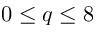Convert formula to latex. <formula><loc_0><loc_0><loc_500><loc_500>0 \leq q \leq 8</formula> 